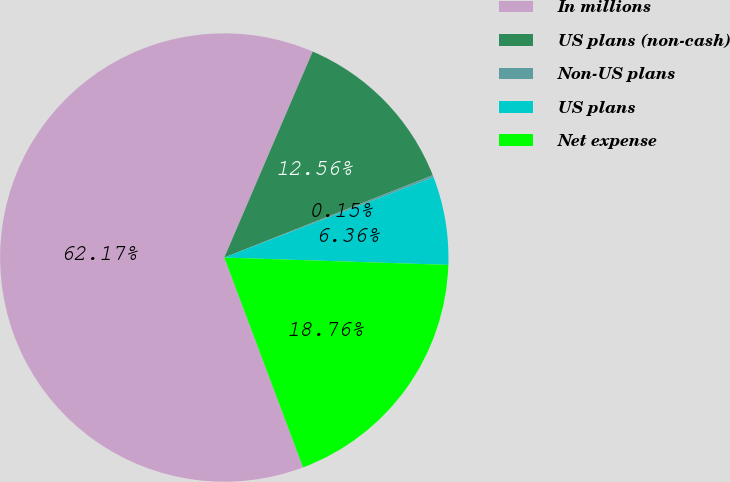Convert chart. <chart><loc_0><loc_0><loc_500><loc_500><pie_chart><fcel>In millions<fcel>US plans (non-cash)<fcel>Non-US plans<fcel>US plans<fcel>Net expense<nl><fcel>62.17%<fcel>12.56%<fcel>0.15%<fcel>6.36%<fcel>18.76%<nl></chart> 